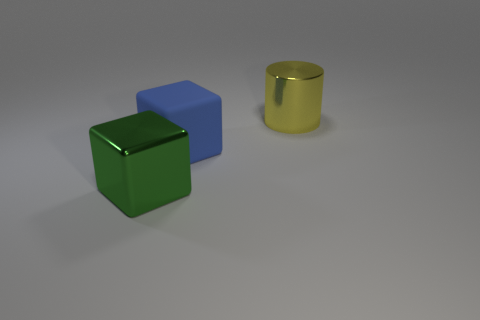Add 1 purple shiny balls. How many objects exist? 4 Subtract all cubes. How many objects are left? 1 Add 2 large matte blocks. How many large matte blocks exist? 3 Subtract 0 yellow balls. How many objects are left? 3 Subtract all blue blocks. Subtract all green things. How many objects are left? 1 Add 1 yellow things. How many yellow things are left? 2 